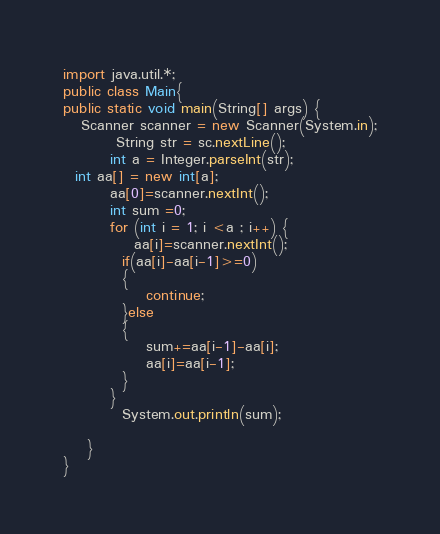Convert code to text. <code><loc_0><loc_0><loc_500><loc_500><_Java_>import java.util.*;
public class Main{   
public static void main(String[] args) {
   Scanner scanner = new Scanner(System.in);
         String str = sc.nextLine();
        int a = Integer.parseInt(str);
  int aa[] = new int[a];
        aa[0]=scanner.nextInt();
        int sum =0;
        for (int i = 1; i <a ; i++) {
            aa[i]=scanner.nextInt();
          if(aa[i]-aa[i-1]>=0)
          {
              continue;
          }else
          {
              sum+=aa[i-1]-aa[i];
              aa[i]=aa[i-1];
          }
        }
          System.out.println(sum);
    
    }
}</code> 